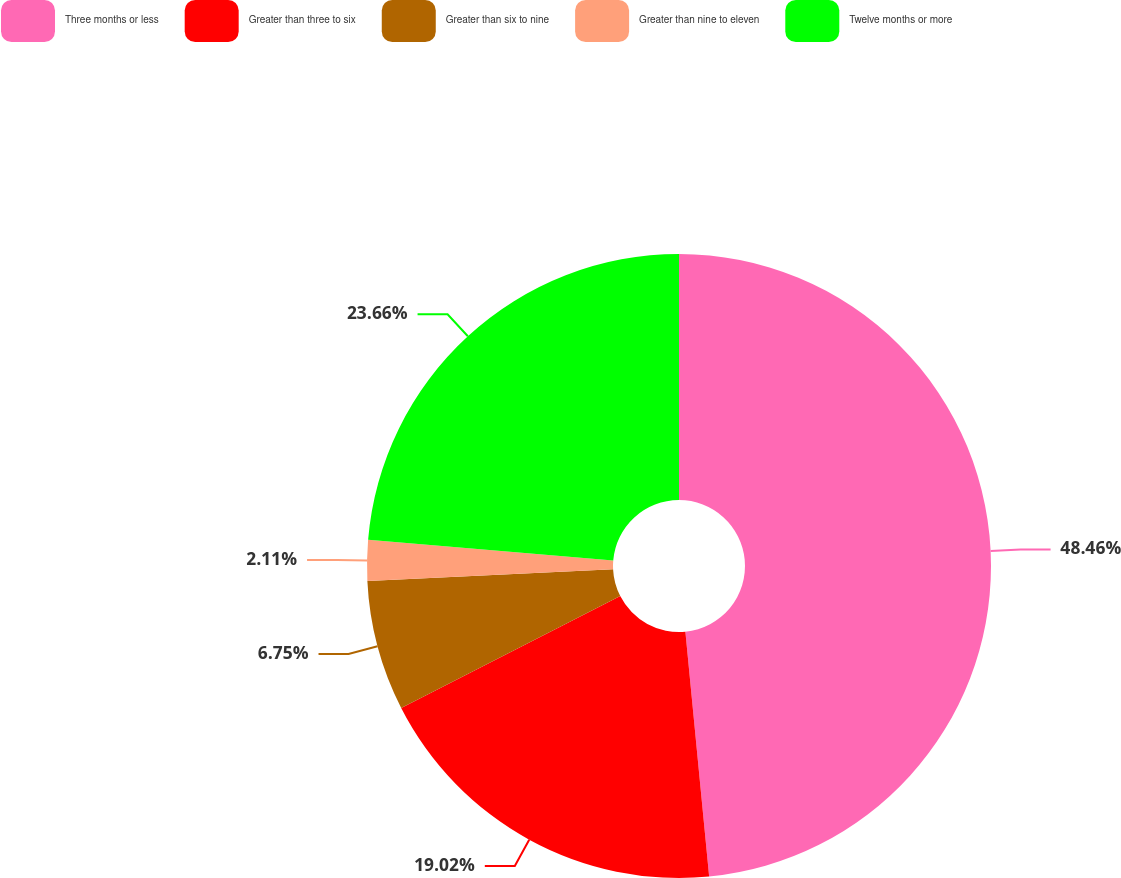Convert chart to OTSL. <chart><loc_0><loc_0><loc_500><loc_500><pie_chart><fcel>Three months or less<fcel>Greater than three to six<fcel>Greater than six to nine<fcel>Greater than nine to eleven<fcel>Twelve months or more<nl><fcel>48.46%<fcel>19.02%<fcel>6.75%<fcel>2.11%<fcel>23.66%<nl></chart> 